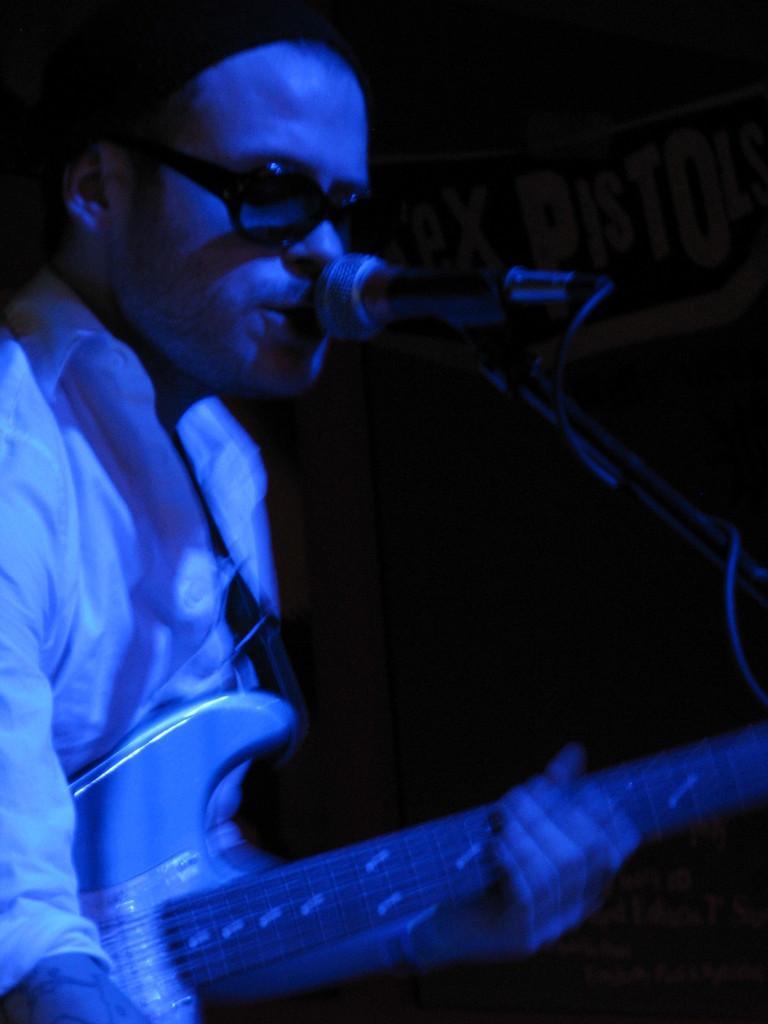How would you summarize this image in a sentence or two? The picture contain a man who is holding a guitar, he is also singing a song, he is wearing black spectacles, in the background there is some banner and a black color wall. 